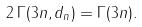<formula> <loc_0><loc_0><loc_500><loc_500>2 \, \Gamma ( 3 n , d _ { n } ) = \Gamma ( 3 n ) .</formula> 